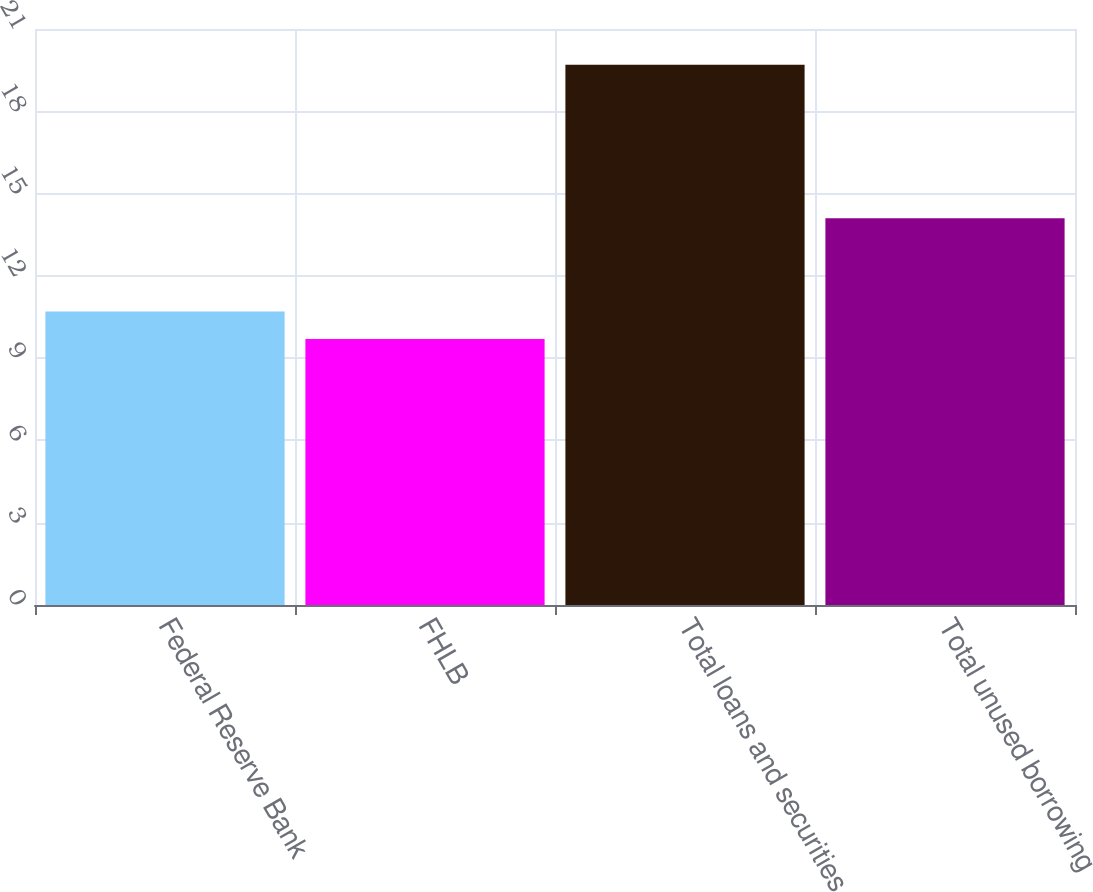Convert chart to OTSL. <chart><loc_0><loc_0><loc_500><loc_500><bar_chart><fcel>Federal Reserve Bank<fcel>FHLB<fcel>Total loans and securities<fcel>Total unused borrowing<nl><fcel>10.7<fcel>9.7<fcel>19.7<fcel>14.1<nl></chart> 